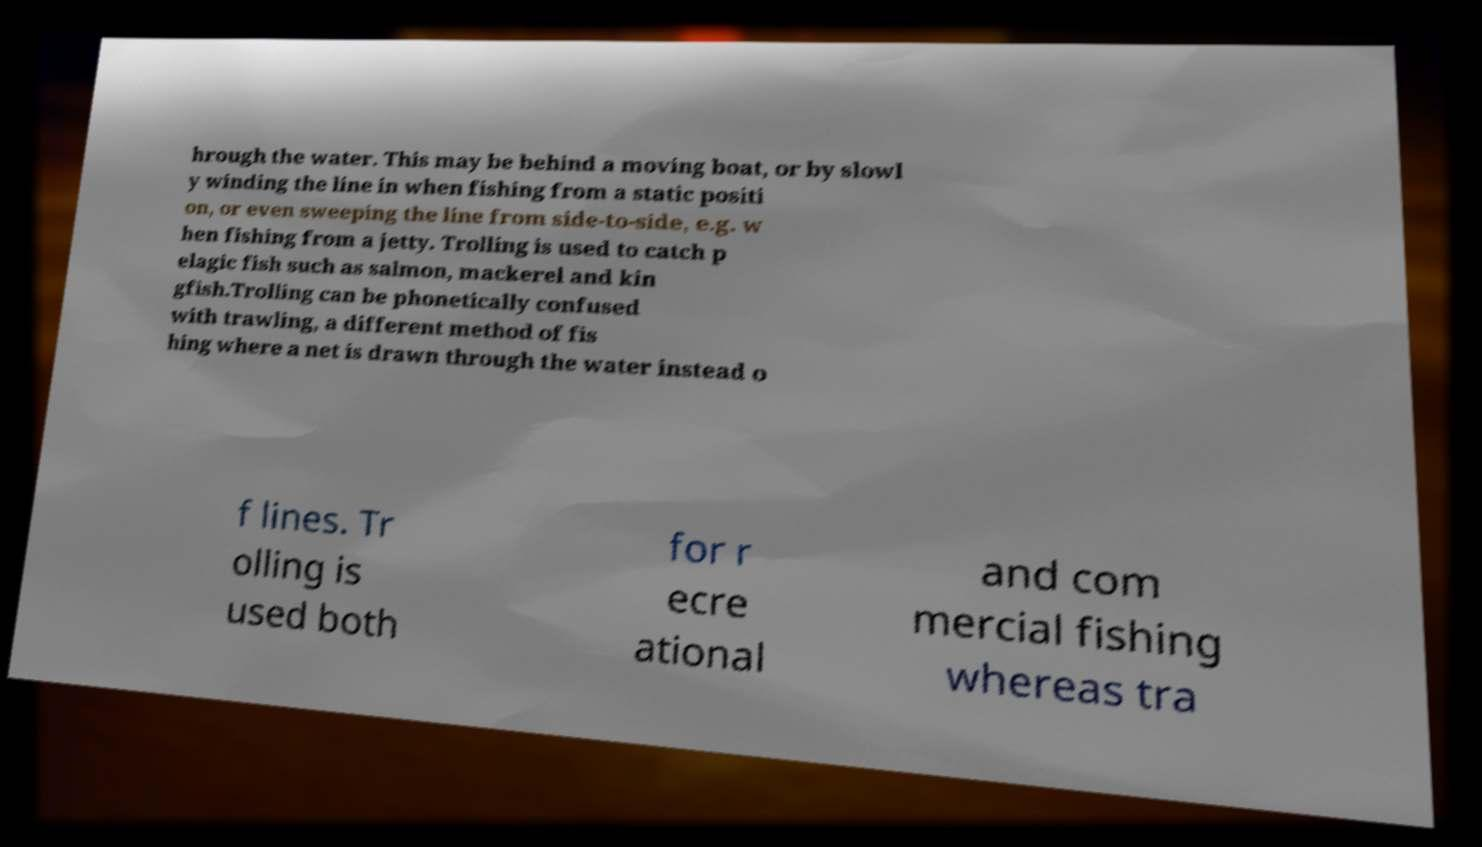I need the written content from this picture converted into text. Can you do that? hrough the water. This may be behind a moving boat, or by slowl y winding the line in when fishing from a static positi on, or even sweeping the line from side-to-side, e.g. w hen fishing from a jetty. Trolling is used to catch p elagic fish such as salmon, mackerel and kin gfish.Trolling can be phonetically confused with trawling, a different method of fis hing where a net is drawn through the water instead o f lines. Tr olling is used both for r ecre ational and com mercial fishing whereas tra 